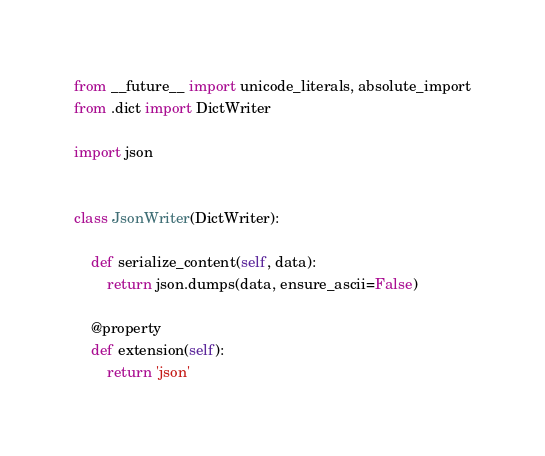<code> <loc_0><loc_0><loc_500><loc_500><_Python_>from __future__ import unicode_literals, absolute_import
from .dict import DictWriter

import json


class JsonWriter(DictWriter):

    def serialize_content(self, data):
        return json.dumps(data, ensure_ascii=False)

    @property
    def extension(self):
        return 'json'
</code> 